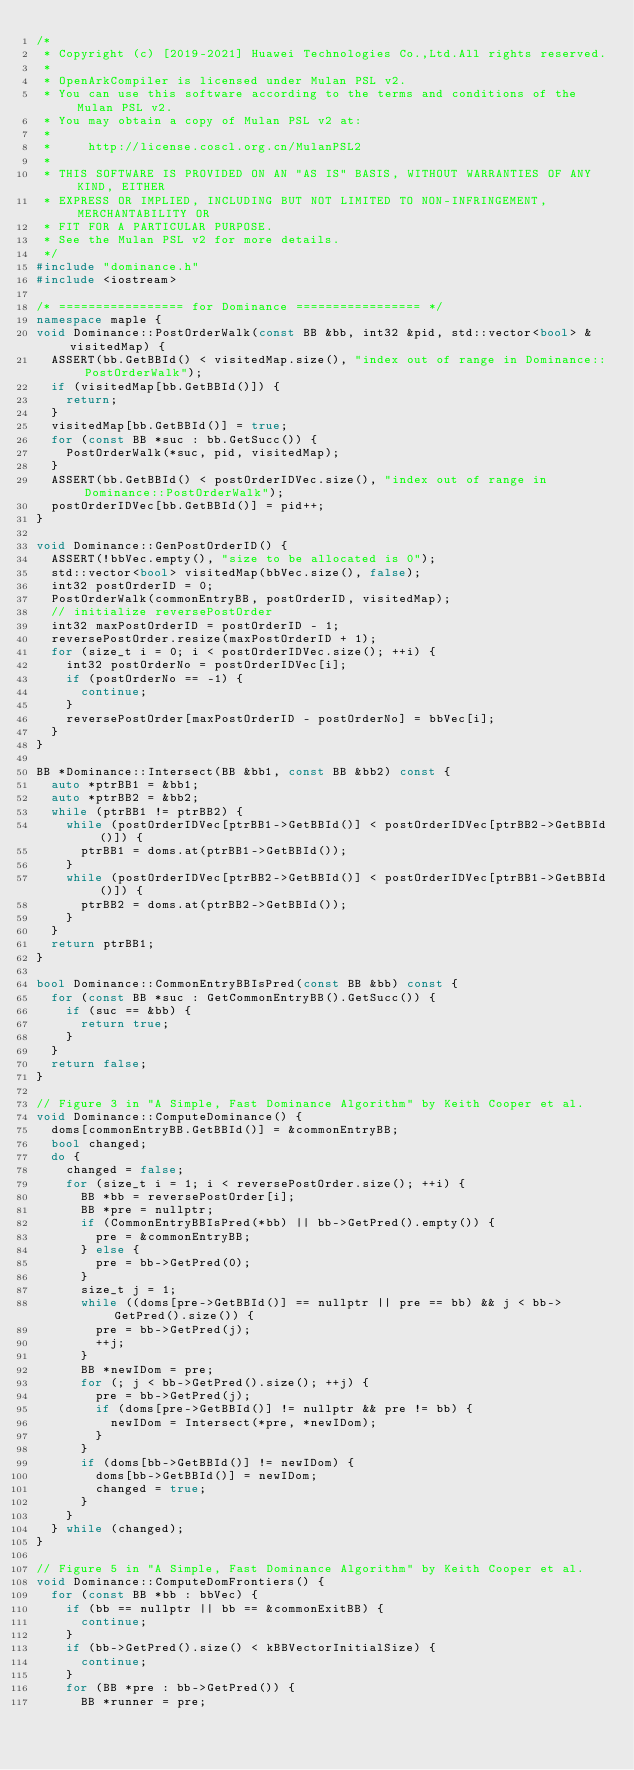Convert code to text. <code><loc_0><loc_0><loc_500><loc_500><_C++_>/*
 * Copyright (c) [2019-2021] Huawei Technologies Co.,Ltd.All rights reserved.
 *
 * OpenArkCompiler is licensed under Mulan PSL v2.
 * You can use this software according to the terms and conditions of the Mulan PSL v2.
 * You may obtain a copy of Mulan PSL v2 at:
 *
 *     http://license.coscl.org.cn/MulanPSL2
 *
 * THIS SOFTWARE IS PROVIDED ON AN "AS IS" BASIS, WITHOUT WARRANTIES OF ANY KIND, EITHER
 * EXPRESS OR IMPLIED, INCLUDING BUT NOT LIMITED TO NON-INFRINGEMENT, MERCHANTABILITY OR
 * FIT FOR A PARTICULAR PURPOSE.
 * See the Mulan PSL v2 for more details.
 */
#include "dominance.h"
#include <iostream>

/* ================= for Dominance ================= */
namespace maple {
void Dominance::PostOrderWalk(const BB &bb, int32 &pid, std::vector<bool> &visitedMap) {
  ASSERT(bb.GetBBId() < visitedMap.size(), "index out of range in Dominance::PostOrderWalk");
  if (visitedMap[bb.GetBBId()]) {
    return;
  }
  visitedMap[bb.GetBBId()] = true;
  for (const BB *suc : bb.GetSucc()) {
    PostOrderWalk(*suc, pid, visitedMap);
  }
  ASSERT(bb.GetBBId() < postOrderIDVec.size(), "index out of range in Dominance::PostOrderWalk");
  postOrderIDVec[bb.GetBBId()] = pid++;
}

void Dominance::GenPostOrderID() {
  ASSERT(!bbVec.empty(), "size to be allocated is 0");
  std::vector<bool> visitedMap(bbVec.size(), false);
  int32 postOrderID = 0;
  PostOrderWalk(commonEntryBB, postOrderID, visitedMap);
  // initialize reversePostOrder
  int32 maxPostOrderID = postOrderID - 1;
  reversePostOrder.resize(maxPostOrderID + 1);
  for (size_t i = 0; i < postOrderIDVec.size(); ++i) {
    int32 postOrderNo = postOrderIDVec[i];
    if (postOrderNo == -1) {
      continue;
    }
    reversePostOrder[maxPostOrderID - postOrderNo] = bbVec[i];
  }
}

BB *Dominance::Intersect(BB &bb1, const BB &bb2) const {
  auto *ptrBB1 = &bb1;
  auto *ptrBB2 = &bb2;
  while (ptrBB1 != ptrBB2) {
    while (postOrderIDVec[ptrBB1->GetBBId()] < postOrderIDVec[ptrBB2->GetBBId()]) {
      ptrBB1 = doms.at(ptrBB1->GetBBId());
    }
    while (postOrderIDVec[ptrBB2->GetBBId()] < postOrderIDVec[ptrBB1->GetBBId()]) {
      ptrBB2 = doms.at(ptrBB2->GetBBId());
    }
  }
  return ptrBB1;
}

bool Dominance::CommonEntryBBIsPred(const BB &bb) const {
  for (const BB *suc : GetCommonEntryBB().GetSucc()) {
    if (suc == &bb) {
      return true;
    }
  }
  return false;
}

// Figure 3 in "A Simple, Fast Dominance Algorithm" by Keith Cooper et al.
void Dominance::ComputeDominance() {
  doms[commonEntryBB.GetBBId()] = &commonEntryBB;
  bool changed;
  do {
    changed = false;
    for (size_t i = 1; i < reversePostOrder.size(); ++i) {
      BB *bb = reversePostOrder[i];
      BB *pre = nullptr;
      if (CommonEntryBBIsPred(*bb) || bb->GetPred().empty()) {
        pre = &commonEntryBB;
      } else {
        pre = bb->GetPred(0);
      }
      size_t j = 1;
      while ((doms[pre->GetBBId()] == nullptr || pre == bb) && j < bb->GetPred().size()) {
        pre = bb->GetPred(j);
        ++j;
      }
      BB *newIDom = pre;
      for (; j < bb->GetPred().size(); ++j) {
        pre = bb->GetPred(j);
        if (doms[pre->GetBBId()] != nullptr && pre != bb) {
          newIDom = Intersect(*pre, *newIDom);
        }
      }
      if (doms[bb->GetBBId()] != newIDom) {
        doms[bb->GetBBId()] = newIDom;
        changed = true;
      }
    }
  } while (changed);
}

// Figure 5 in "A Simple, Fast Dominance Algorithm" by Keith Cooper et al.
void Dominance::ComputeDomFrontiers() {
  for (const BB *bb : bbVec) {
    if (bb == nullptr || bb == &commonExitBB) {
      continue;
    }
    if (bb->GetPred().size() < kBBVectorInitialSize) {
      continue;
    }
    for (BB *pre : bb->GetPred()) {
      BB *runner = pre;</code> 